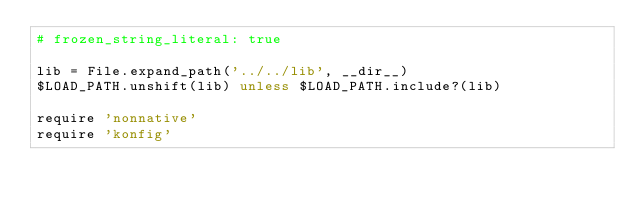Convert code to text. <code><loc_0><loc_0><loc_500><loc_500><_Ruby_># frozen_string_literal: true

lib = File.expand_path('../../lib', __dir__)
$LOAD_PATH.unshift(lib) unless $LOAD_PATH.include?(lib)

require 'nonnative'
require 'konfig'
</code> 